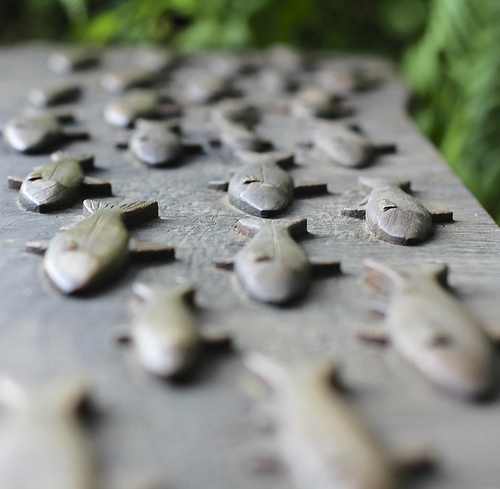<image>
Is there a fish on the wood? Yes. Looking at the image, I can see the fish is positioned on top of the wood, with the wood providing support. 